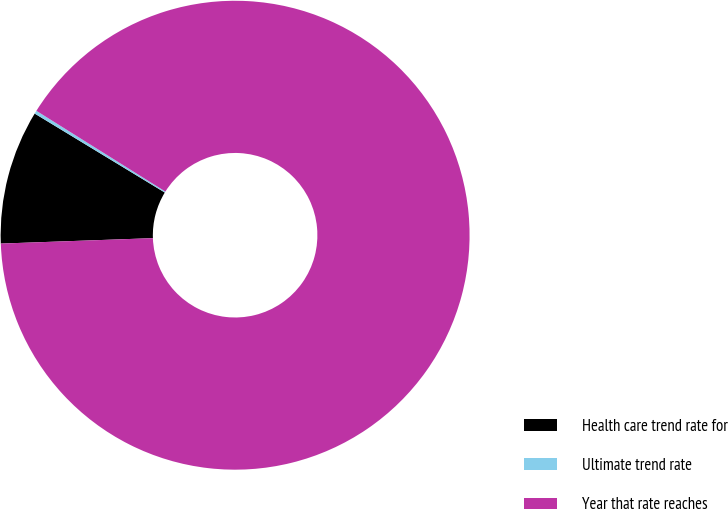Convert chart to OTSL. <chart><loc_0><loc_0><loc_500><loc_500><pie_chart><fcel>Health care trend rate for<fcel>Ultimate trend rate<fcel>Year that rate reaches<nl><fcel>9.25%<fcel>0.22%<fcel>90.52%<nl></chart> 